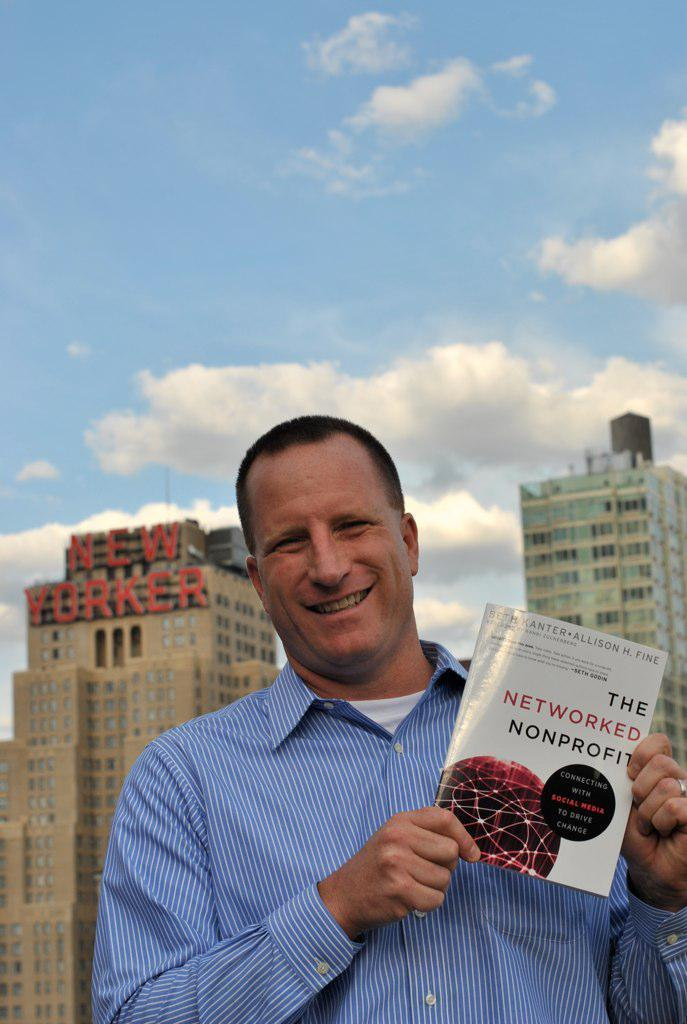<image>
Relay a brief, clear account of the picture shown. A man posing holding a book titled The Networked Nonprofit. 